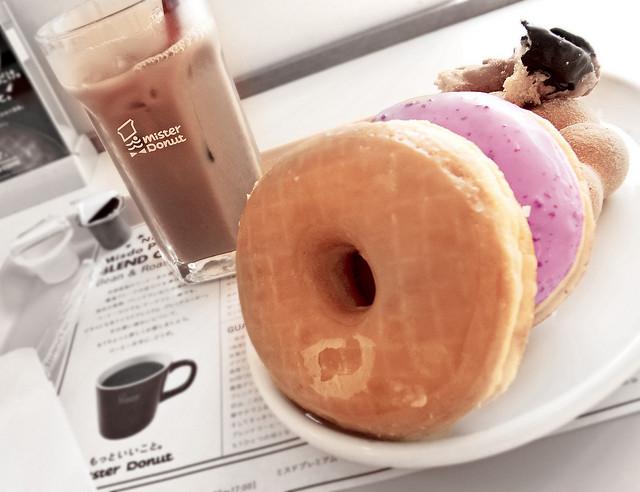Is there a picture of a cup of coffee on the menu?
Be succinct. Yes. Are these plain bagels?
Be succinct. No. Could someone pick up the coffee cup to the left of the donuts?
Give a very brief answer. Yes. Is there frosting on any of the doughnuts?
Keep it brief. Yes. 